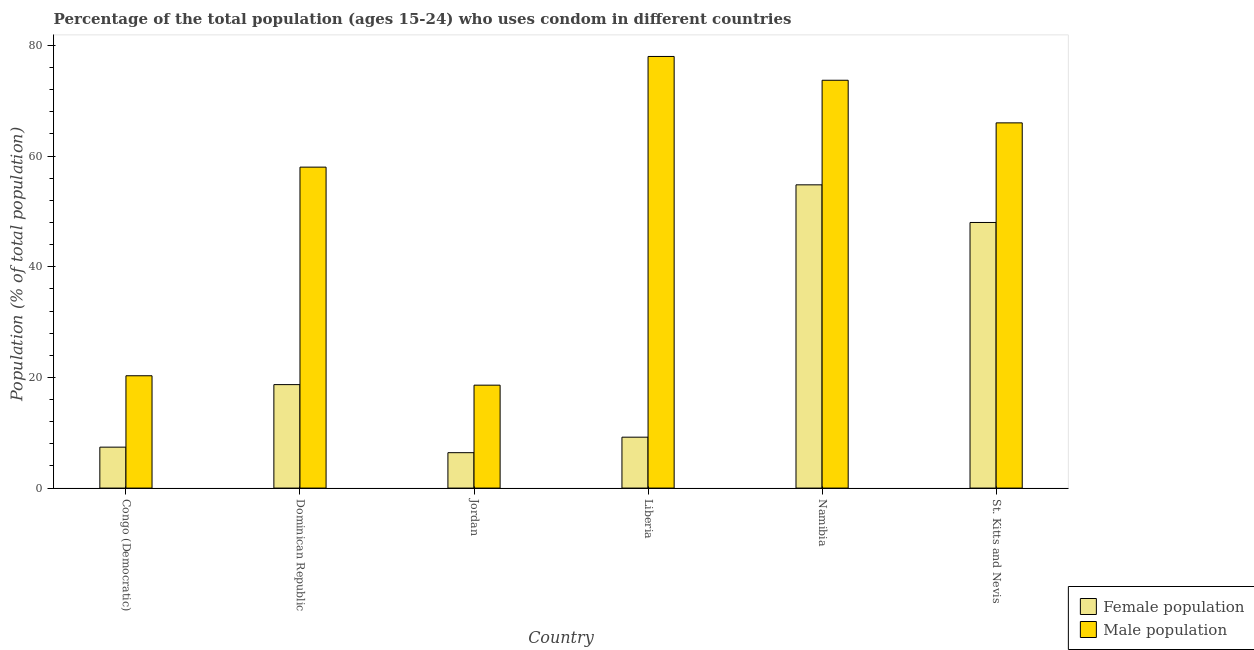Are the number of bars per tick equal to the number of legend labels?
Your answer should be compact. Yes. Are the number of bars on each tick of the X-axis equal?
Offer a terse response. Yes. What is the label of the 4th group of bars from the left?
Keep it short and to the point. Liberia. In how many cases, is the number of bars for a given country not equal to the number of legend labels?
Keep it short and to the point. 0. What is the female population in St. Kitts and Nevis?
Provide a short and direct response. 48. Across all countries, what is the maximum female population?
Your answer should be very brief. 54.8. Across all countries, what is the minimum female population?
Provide a short and direct response. 6.4. In which country was the female population maximum?
Provide a short and direct response. Namibia. In which country was the female population minimum?
Provide a succinct answer. Jordan. What is the total male population in the graph?
Offer a very short reply. 314.6. What is the difference between the male population in Liberia and that in Namibia?
Keep it short and to the point. 4.3. What is the difference between the female population in Congo (Democratic) and the male population in Dominican Republic?
Offer a very short reply. -50.6. What is the average male population per country?
Offer a very short reply. 52.43. What is the difference between the male population and female population in Jordan?
Your answer should be very brief. 12.2. What is the ratio of the female population in Dominican Republic to that in Liberia?
Your answer should be very brief. 2.03. Is the female population in Jordan less than that in St. Kitts and Nevis?
Ensure brevity in your answer.  Yes. Is the difference between the female population in Liberia and St. Kitts and Nevis greater than the difference between the male population in Liberia and St. Kitts and Nevis?
Offer a very short reply. No. What is the difference between the highest and the second highest male population?
Give a very brief answer. 4.3. What is the difference between the highest and the lowest male population?
Provide a short and direct response. 59.4. What does the 2nd bar from the left in St. Kitts and Nevis represents?
Provide a short and direct response. Male population. What does the 1st bar from the right in Congo (Democratic) represents?
Ensure brevity in your answer.  Male population. How many bars are there?
Give a very brief answer. 12. Are all the bars in the graph horizontal?
Provide a succinct answer. No. How many countries are there in the graph?
Ensure brevity in your answer.  6. What is the difference between two consecutive major ticks on the Y-axis?
Provide a short and direct response. 20. Are the values on the major ticks of Y-axis written in scientific E-notation?
Ensure brevity in your answer.  No. Where does the legend appear in the graph?
Your answer should be compact. Bottom right. How are the legend labels stacked?
Your answer should be compact. Vertical. What is the title of the graph?
Give a very brief answer. Percentage of the total population (ages 15-24) who uses condom in different countries. Does "Education" appear as one of the legend labels in the graph?
Your answer should be compact. No. What is the label or title of the X-axis?
Provide a short and direct response. Country. What is the label or title of the Y-axis?
Your response must be concise. Population (% of total population) . What is the Population (% of total population)  of Female population in Congo (Democratic)?
Ensure brevity in your answer.  7.4. What is the Population (% of total population)  in Male population in Congo (Democratic)?
Provide a short and direct response. 20.3. What is the Population (% of total population)  in Female population in Jordan?
Your answer should be compact. 6.4. What is the Population (% of total population)  in Male population in Jordan?
Make the answer very short. 18.6. What is the Population (% of total population)  of Female population in Liberia?
Provide a succinct answer. 9.2. What is the Population (% of total population)  in Female population in Namibia?
Keep it short and to the point. 54.8. What is the Population (% of total population)  of Male population in Namibia?
Make the answer very short. 73.7. Across all countries, what is the maximum Population (% of total population)  in Female population?
Keep it short and to the point. 54.8. Across all countries, what is the maximum Population (% of total population)  in Male population?
Make the answer very short. 78. What is the total Population (% of total population)  in Female population in the graph?
Offer a very short reply. 144.5. What is the total Population (% of total population)  of Male population in the graph?
Give a very brief answer. 314.6. What is the difference between the Population (% of total population)  in Female population in Congo (Democratic) and that in Dominican Republic?
Your response must be concise. -11.3. What is the difference between the Population (% of total population)  in Male population in Congo (Democratic) and that in Dominican Republic?
Your response must be concise. -37.7. What is the difference between the Population (% of total population)  of Male population in Congo (Democratic) and that in Jordan?
Your answer should be very brief. 1.7. What is the difference between the Population (% of total population)  in Female population in Congo (Democratic) and that in Liberia?
Make the answer very short. -1.8. What is the difference between the Population (% of total population)  in Male population in Congo (Democratic) and that in Liberia?
Keep it short and to the point. -57.7. What is the difference between the Population (% of total population)  of Female population in Congo (Democratic) and that in Namibia?
Your response must be concise. -47.4. What is the difference between the Population (% of total population)  of Male population in Congo (Democratic) and that in Namibia?
Keep it short and to the point. -53.4. What is the difference between the Population (% of total population)  of Female population in Congo (Democratic) and that in St. Kitts and Nevis?
Make the answer very short. -40.6. What is the difference between the Population (% of total population)  of Male population in Congo (Democratic) and that in St. Kitts and Nevis?
Offer a terse response. -45.7. What is the difference between the Population (% of total population)  of Male population in Dominican Republic and that in Jordan?
Make the answer very short. 39.4. What is the difference between the Population (% of total population)  of Female population in Dominican Republic and that in Liberia?
Your answer should be very brief. 9.5. What is the difference between the Population (% of total population)  of Male population in Dominican Republic and that in Liberia?
Offer a terse response. -20. What is the difference between the Population (% of total population)  of Female population in Dominican Republic and that in Namibia?
Your answer should be very brief. -36.1. What is the difference between the Population (% of total population)  in Male population in Dominican Republic and that in Namibia?
Ensure brevity in your answer.  -15.7. What is the difference between the Population (% of total population)  of Female population in Dominican Republic and that in St. Kitts and Nevis?
Keep it short and to the point. -29.3. What is the difference between the Population (% of total population)  of Female population in Jordan and that in Liberia?
Offer a terse response. -2.8. What is the difference between the Population (% of total population)  of Male population in Jordan and that in Liberia?
Provide a short and direct response. -59.4. What is the difference between the Population (% of total population)  of Female population in Jordan and that in Namibia?
Keep it short and to the point. -48.4. What is the difference between the Population (% of total population)  of Male population in Jordan and that in Namibia?
Your response must be concise. -55.1. What is the difference between the Population (% of total population)  in Female population in Jordan and that in St. Kitts and Nevis?
Keep it short and to the point. -41.6. What is the difference between the Population (% of total population)  of Male population in Jordan and that in St. Kitts and Nevis?
Provide a short and direct response. -47.4. What is the difference between the Population (% of total population)  in Female population in Liberia and that in Namibia?
Make the answer very short. -45.6. What is the difference between the Population (% of total population)  of Female population in Liberia and that in St. Kitts and Nevis?
Offer a terse response. -38.8. What is the difference between the Population (% of total population)  of Female population in Namibia and that in St. Kitts and Nevis?
Keep it short and to the point. 6.8. What is the difference between the Population (% of total population)  in Male population in Namibia and that in St. Kitts and Nevis?
Provide a succinct answer. 7.7. What is the difference between the Population (% of total population)  of Female population in Congo (Democratic) and the Population (% of total population)  of Male population in Dominican Republic?
Make the answer very short. -50.6. What is the difference between the Population (% of total population)  in Female population in Congo (Democratic) and the Population (% of total population)  in Male population in Liberia?
Make the answer very short. -70.6. What is the difference between the Population (% of total population)  in Female population in Congo (Democratic) and the Population (% of total population)  in Male population in Namibia?
Your response must be concise. -66.3. What is the difference between the Population (% of total population)  of Female population in Congo (Democratic) and the Population (% of total population)  of Male population in St. Kitts and Nevis?
Your answer should be very brief. -58.6. What is the difference between the Population (% of total population)  of Female population in Dominican Republic and the Population (% of total population)  of Male population in Liberia?
Your answer should be compact. -59.3. What is the difference between the Population (% of total population)  in Female population in Dominican Republic and the Population (% of total population)  in Male population in Namibia?
Your response must be concise. -55. What is the difference between the Population (% of total population)  in Female population in Dominican Republic and the Population (% of total population)  in Male population in St. Kitts and Nevis?
Make the answer very short. -47.3. What is the difference between the Population (% of total population)  of Female population in Jordan and the Population (% of total population)  of Male population in Liberia?
Your response must be concise. -71.6. What is the difference between the Population (% of total population)  of Female population in Jordan and the Population (% of total population)  of Male population in Namibia?
Provide a short and direct response. -67.3. What is the difference between the Population (% of total population)  in Female population in Jordan and the Population (% of total population)  in Male population in St. Kitts and Nevis?
Give a very brief answer. -59.6. What is the difference between the Population (% of total population)  of Female population in Liberia and the Population (% of total population)  of Male population in Namibia?
Offer a very short reply. -64.5. What is the difference between the Population (% of total population)  in Female population in Liberia and the Population (% of total population)  in Male population in St. Kitts and Nevis?
Provide a short and direct response. -56.8. What is the difference between the Population (% of total population)  of Female population in Namibia and the Population (% of total population)  of Male population in St. Kitts and Nevis?
Give a very brief answer. -11.2. What is the average Population (% of total population)  of Female population per country?
Offer a terse response. 24.08. What is the average Population (% of total population)  in Male population per country?
Offer a very short reply. 52.43. What is the difference between the Population (% of total population)  of Female population and Population (% of total population)  of Male population in Dominican Republic?
Offer a very short reply. -39.3. What is the difference between the Population (% of total population)  in Female population and Population (% of total population)  in Male population in Liberia?
Offer a very short reply. -68.8. What is the difference between the Population (% of total population)  of Female population and Population (% of total population)  of Male population in Namibia?
Provide a succinct answer. -18.9. What is the ratio of the Population (% of total population)  of Female population in Congo (Democratic) to that in Dominican Republic?
Your response must be concise. 0.4. What is the ratio of the Population (% of total population)  in Female population in Congo (Democratic) to that in Jordan?
Give a very brief answer. 1.16. What is the ratio of the Population (% of total population)  in Male population in Congo (Democratic) to that in Jordan?
Provide a short and direct response. 1.09. What is the ratio of the Population (% of total population)  of Female population in Congo (Democratic) to that in Liberia?
Keep it short and to the point. 0.8. What is the ratio of the Population (% of total population)  of Male population in Congo (Democratic) to that in Liberia?
Offer a very short reply. 0.26. What is the ratio of the Population (% of total population)  in Female population in Congo (Democratic) to that in Namibia?
Ensure brevity in your answer.  0.14. What is the ratio of the Population (% of total population)  in Male population in Congo (Democratic) to that in Namibia?
Offer a very short reply. 0.28. What is the ratio of the Population (% of total population)  of Female population in Congo (Democratic) to that in St. Kitts and Nevis?
Offer a terse response. 0.15. What is the ratio of the Population (% of total population)  of Male population in Congo (Democratic) to that in St. Kitts and Nevis?
Your response must be concise. 0.31. What is the ratio of the Population (% of total population)  of Female population in Dominican Republic to that in Jordan?
Offer a very short reply. 2.92. What is the ratio of the Population (% of total population)  in Male population in Dominican Republic to that in Jordan?
Keep it short and to the point. 3.12. What is the ratio of the Population (% of total population)  in Female population in Dominican Republic to that in Liberia?
Your answer should be very brief. 2.03. What is the ratio of the Population (% of total population)  of Male population in Dominican Republic to that in Liberia?
Provide a succinct answer. 0.74. What is the ratio of the Population (% of total population)  in Female population in Dominican Republic to that in Namibia?
Offer a very short reply. 0.34. What is the ratio of the Population (% of total population)  in Male population in Dominican Republic to that in Namibia?
Offer a terse response. 0.79. What is the ratio of the Population (% of total population)  in Female population in Dominican Republic to that in St. Kitts and Nevis?
Your answer should be compact. 0.39. What is the ratio of the Population (% of total population)  in Male population in Dominican Republic to that in St. Kitts and Nevis?
Offer a very short reply. 0.88. What is the ratio of the Population (% of total population)  of Female population in Jordan to that in Liberia?
Make the answer very short. 0.7. What is the ratio of the Population (% of total population)  of Male population in Jordan to that in Liberia?
Ensure brevity in your answer.  0.24. What is the ratio of the Population (% of total population)  in Female population in Jordan to that in Namibia?
Ensure brevity in your answer.  0.12. What is the ratio of the Population (% of total population)  of Male population in Jordan to that in Namibia?
Keep it short and to the point. 0.25. What is the ratio of the Population (% of total population)  of Female population in Jordan to that in St. Kitts and Nevis?
Provide a short and direct response. 0.13. What is the ratio of the Population (% of total population)  in Male population in Jordan to that in St. Kitts and Nevis?
Your answer should be compact. 0.28. What is the ratio of the Population (% of total population)  of Female population in Liberia to that in Namibia?
Keep it short and to the point. 0.17. What is the ratio of the Population (% of total population)  in Male population in Liberia to that in Namibia?
Your answer should be very brief. 1.06. What is the ratio of the Population (% of total population)  of Female population in Liberia to that in St. Kitts and Nevis?
Offer a terse response. 0.19. What is the ratio of the Population (% of total population)  in Male population in Liberia to that in St. Kitts and Nevis?
Provide a succinct answer. 1.18. What is the ratio of the Population (% of total population)  of Female population in Namibia to that in St. Kitts and Nevis?
Ensure brevity in your answer.  1.14. What is the ratio of the Population (% of total population)  of Male population in Namibia to that in St. Kitts and Nevis?
Give a very brief answer. 1.12. What is the difference between the highest and the second highest Population (% of total population)  in Male population?
Provide a short and direct response. 4.3. What is the difference between the highest and the lowest Population (% of total population)  in Female population?
Keep it short and to the point. 48.4. What is the difference between the highest and the lowest Population (% of total population)  of Male population?
Provide a short and direct response. 59.4. 